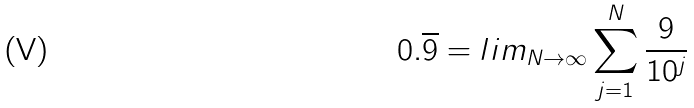<formula> <loc_0><loc_0><loc_500><loc_500>0 . \overline { 9 } = l i m _ { N \rightarrow \infty } \sum _ { j = 1 } ^ { N } \frac { 9 } { 1 0 ^ { j } }</formula> 